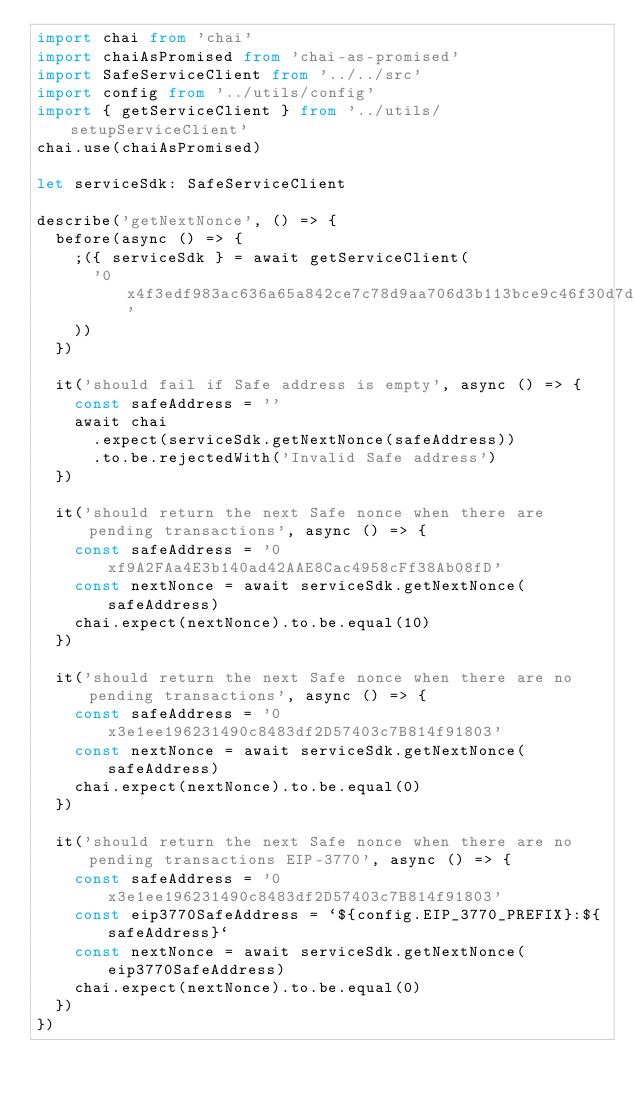Convert code to text. <code><loc_0><loc_0><loc_500><loc_500><_TypeScript_>import chai from 'chai'
import chaiAsPromised from 'chai-as-promised'
import SafeServiceClient from '../../src'
import config from '../utils/config'
import { getServiceClient } from '../utils/setupServiceClient'
chai.use(chaiAsPromised)

let serviceSdk: SafeServiceClient

describe('getNextNonce', () => {
  before(async () => {
    ;({ serviceSdk } = await getServiceClient(
      '0x4f3edf983ac636a65a842ce7c78d9aa706d3b113bce9c46f30d7d21715b23b1d'
    ))
  })

  it('should fail if Safe address is empty', async () => {
    const safeAddress = ''
    await chai
      .expect(serviceSdk.getNextNonce(safeAddress))
      .to.be.rejectedWith('Invalid Safe address')
  })

  it('should return the next Safe nonce when there are pending transactions', async () => {
    const safeAddress = '0xf9A2FAa4E3b140ad42AAE8Cac4958cFf38Ab08fD'
    const nextNonce = await serviceSdk.getNextNonce(safeAddress)
    chai.expect(nextNonce).to.be.equal(10)
  })

  it('should return the next Safe nonce when there are no pending transactions', async () => {
    const safeAddress = '0x3e1ee196231490c8483df2D57403c7B814f91803'
    const nextNonce = await serviceSdk.getNextNonce(safeAddress)
    chai.expect(nextNonce).to.be.equal(0)
  })

  it('should return the next Safe nonce when there are no pending transactions EIP-3770', async () => {
    const safeAddress = '0x3e1ee196231490c8483df2D57403c7B814f91803'
    const eip3770SafeAddress = `${config.EIP_3770_PREFIX}:${safeAddress}`
    const nextNonce = await serviceSdk.getNextNonce(eip3770SafeAddress)
    chai.expect(nextNonce).to.be.equal(0)
  })
})
</code> 